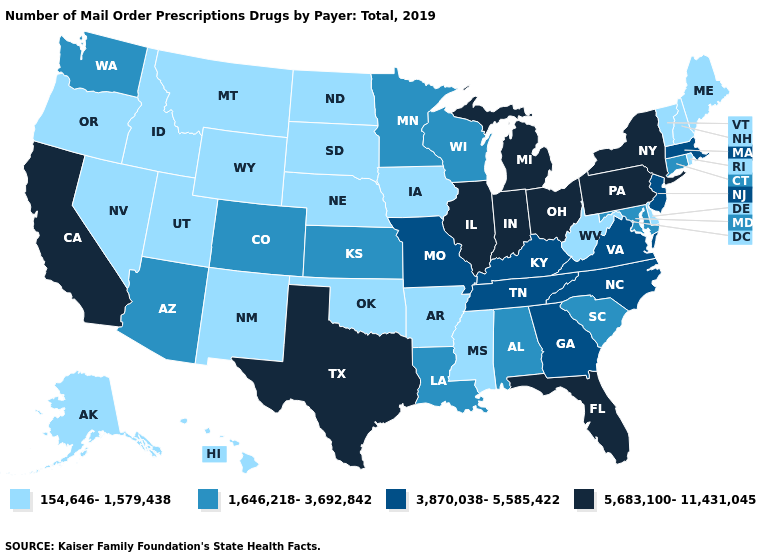Among the states that border Florida , which have the lowest value?
Short answer required. Alabama. Is the legend a continuous bar?
Write a very short answer. No. Does New York have the lowest value in the Northeast?
Short answer required. No. Name the states that have a value in the range 3,870,038-5,585,422?
Short answer required. Georgia, Kentucky, Massachusetts, Missouri, New Jersey, North Carolina, Tennessee, Virginia. Which states have the highest value in the USA?
Be succinct. California, Florida, Illinois, Indiana, Michigan, New York, Ohio, Pennsylvania, Texas. Does Arkansas have a lower value than Michigan?
Answer briefly. Yes. What is the value of New Hampshire?
Keep it brief. 154,646-1,579,438. Among the states that border Oregon , which have the highest value?
Answer briefly. California. Does Connecticut have the lowest value in the USA?
Keep it brief. No. Name the states that have a value in the range 3,870,038-5,585,422?
Short answer required. Georgia, Kentucky, Massachusetts, Missouri, New Jersey, North Carolina, Tennessee, Virginia. What is the highest value in states that border North Dakota?
Keep it brief. 1,646,218-3,692,842. Does Florida have the lowest value in the USA?
Quick response, please. No. Among the states that border South Dakota , which have the lowest value?
Short answer required. Iowa, Montana, Nebraska, North Dakota, Wyoming. Which states have the lowest value in the West?
Quick response, please. Alaska, Hawaii, Idaho, Montana, Nevada, New Mexico, Oregon, Utah, Wyoming. 